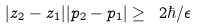Convert formula to latex. <formula><loc_0><loc_0><loc_500><loc_500>| z _ { 2 } - z _ { 1 } | | p _ { 2 } - p _ { 1 } | \geq \ 2 \hbar { / } { \epsilon }</formula> 